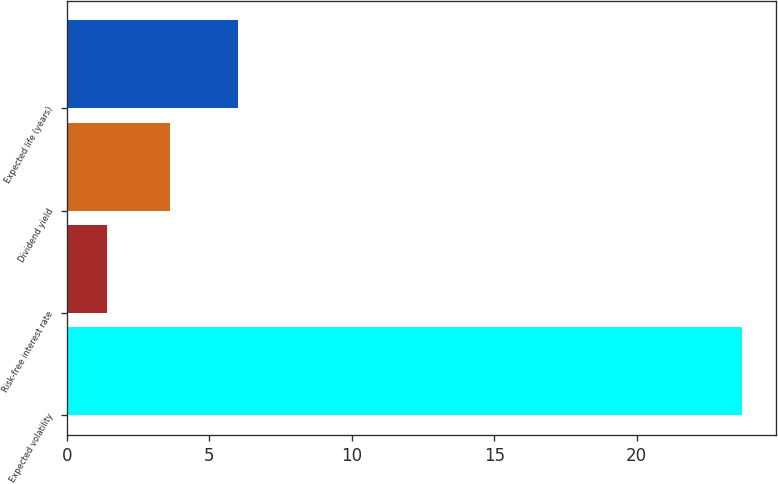<chart> <loc_0><loc_0><loc_500><loc_500><bar_chart><fcel>Expected volatility<fcel>Risk-free interest rate<fcel>Dividend yield<fcel>Expected life (years)<nl><fcel>23.7<fcel>1.4<fcel>3.63<fcel>6<nl></chart> 